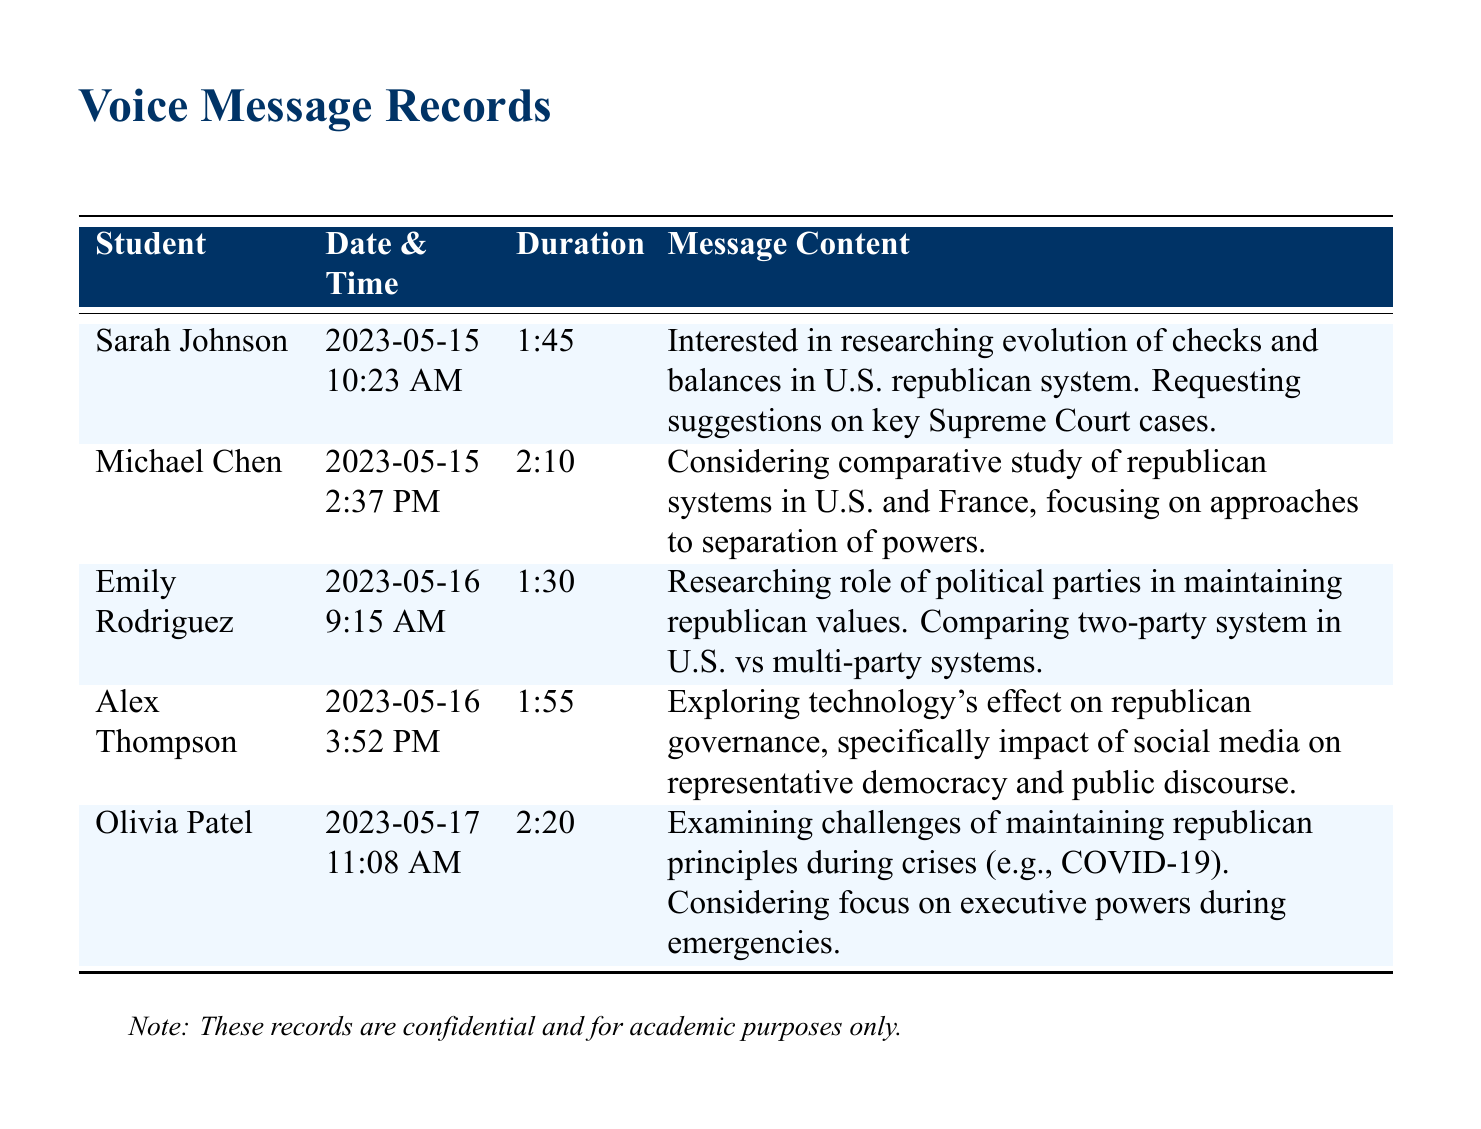What is the name of the student who is researching checks and balances? The message records indicate that Sarah Johnson is interested in researching checks and balances.
Answer: Sarah Johnson When did Michael Chen leave his voice message? Michael Chen's message was recorded on May 15, 2023, at 2:37 PM.
Answer: 2023-05-15 2:37 PM What is the duration of Emily Rodriguez's message? Emily Rodriguez's voice message has a duration of 1 minute and 30 seconds.
Answer: 1:30 What topic is Alex Thompson exploring? Alex Thompson's message indicates he is exploring the impact of social media on representative democracy and public discourse.
Answer: Technology's effect on republican governance What is the primary focus of Olivia Patel's research? Olivia Patel is examining the challenges of maintaining republican principles during crises, particularly regarding executive powers.
Answer: Maintaining republican principles during crises Which student is conducting a comparative study? Michael Chen is considering a comparative study of republican systems in the U.S. and France.
Answer: Michael Chen How many messages were left regarding research topics related to republican governance? Five messages were recorded regarding various research topics on republican governance.
Answer: Five What color is used for the header in the table? The header color in the table is a shade of dark blue with RGB values of (0, 51, 102).
Answer: Dark blue 